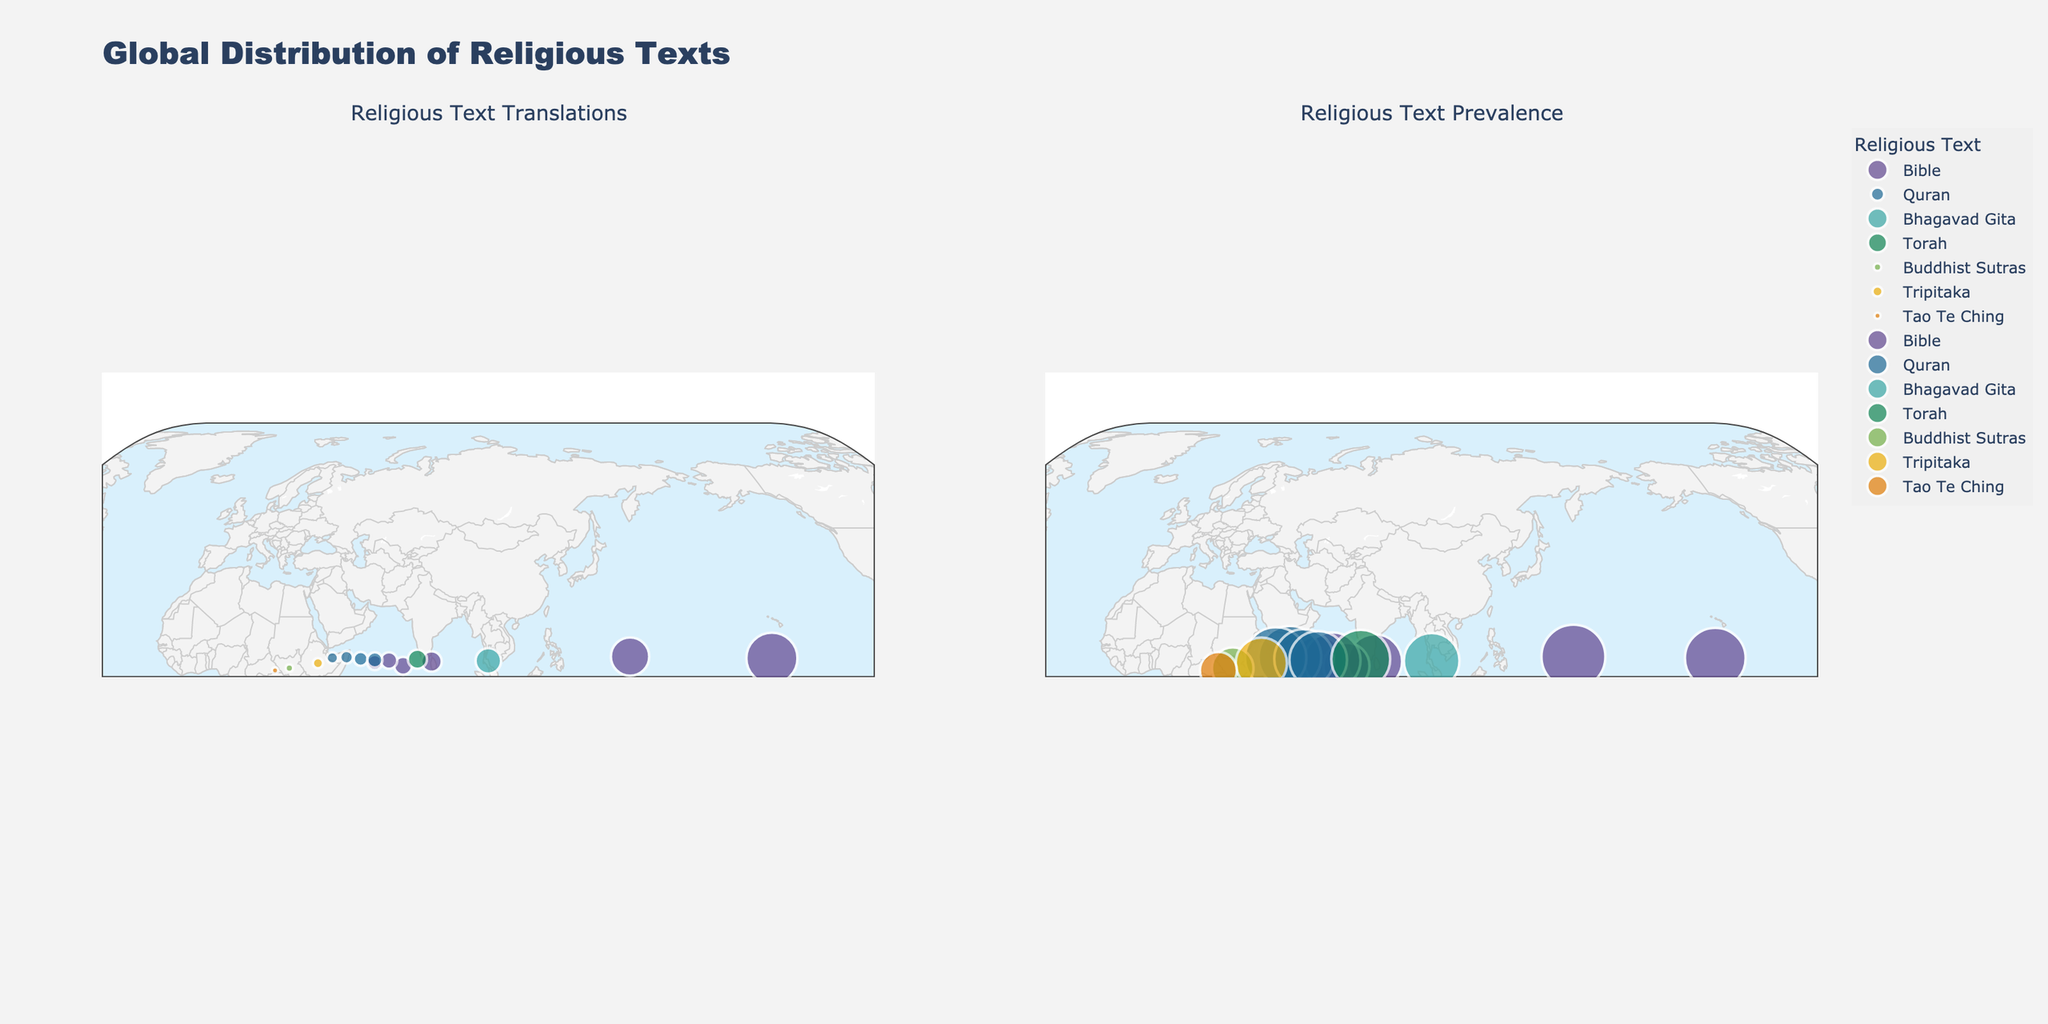What's the main title of the figure? The main title of the figure is prominently displayed at the top and is typically larger than other text. It summarizes the content by stating "Global Distribution of Religious Texts."
Answer: Global Distribution of Religious Texts Which country has the highest prevalence score for the Bible? Look at the data points plotted for the Bible in the "Religious Text Prevalence" scattergeo plot. Identify the country associated with the highest prevalence value on the y-axis.
Answer: Vatican City How many translations of the Quran are there in Saudi Arabia? Locate Saudi Arabia on the "Religious Text Translations" scattergeo plot and check the x-axis value corresponding to the mapped data point.
Answer: 50 What is the average prevalence score for the countries where the Quran is the major religious text? Identify the prevalence scores for Saudi Arabia, Iran, Egypt, and Indonesia from the figure and compute their average: (9.8 + 9.6 + 9.3 + 9.0) / 4.
Answer: 9.43 In which countries is the Torah used as the major religious text, and what is their prevalence score? Look for the data point corresponding to the Torah in both plots. Identify the relevant country (Israel) and note its associated prevalence score from the y-axis.
Answer: Israel, 9.2 Compare the number of Bible translations in the United States and Italy. Which one has more? Refer to the "Religious Text Translations" scattergeo plot and compare the translations indicated along the x-axis for both countries. The United States has 200 translations, while Italy has 80.
Answer: United States Which religious text has the smallest number of translations in the dataset? Identify the data points with the lowest x-axis values in the "Religious Text Translations" scattergeo plot and check their associated texts.
Answer: Tao Te Ching What is the prevalence score for the Tripitaka in Thailand? Locate Thailand on the "Religious Text Prevalence" scattergeo plot and read the corresponding y-axis value for the Tripitaka.
Answer: 8.0 Which country shows translations for Buddhist Sutras, and what is their prevalence score? Identify the data point related to Buddhist Sutras in both plots and find its associated country (Japan) and prevalence score on the y-axis.
Answer: Japan, 6.5 What is the difference in translations between the Torah in Israel and the Bhagavad Gita in India? Refer to the "Religious Text Translations" scattergeo plot, find the translations for both Israel (Torah) and India (Bhagavad Gita), and compute the difference: 100 - 75.
Answer: 25 